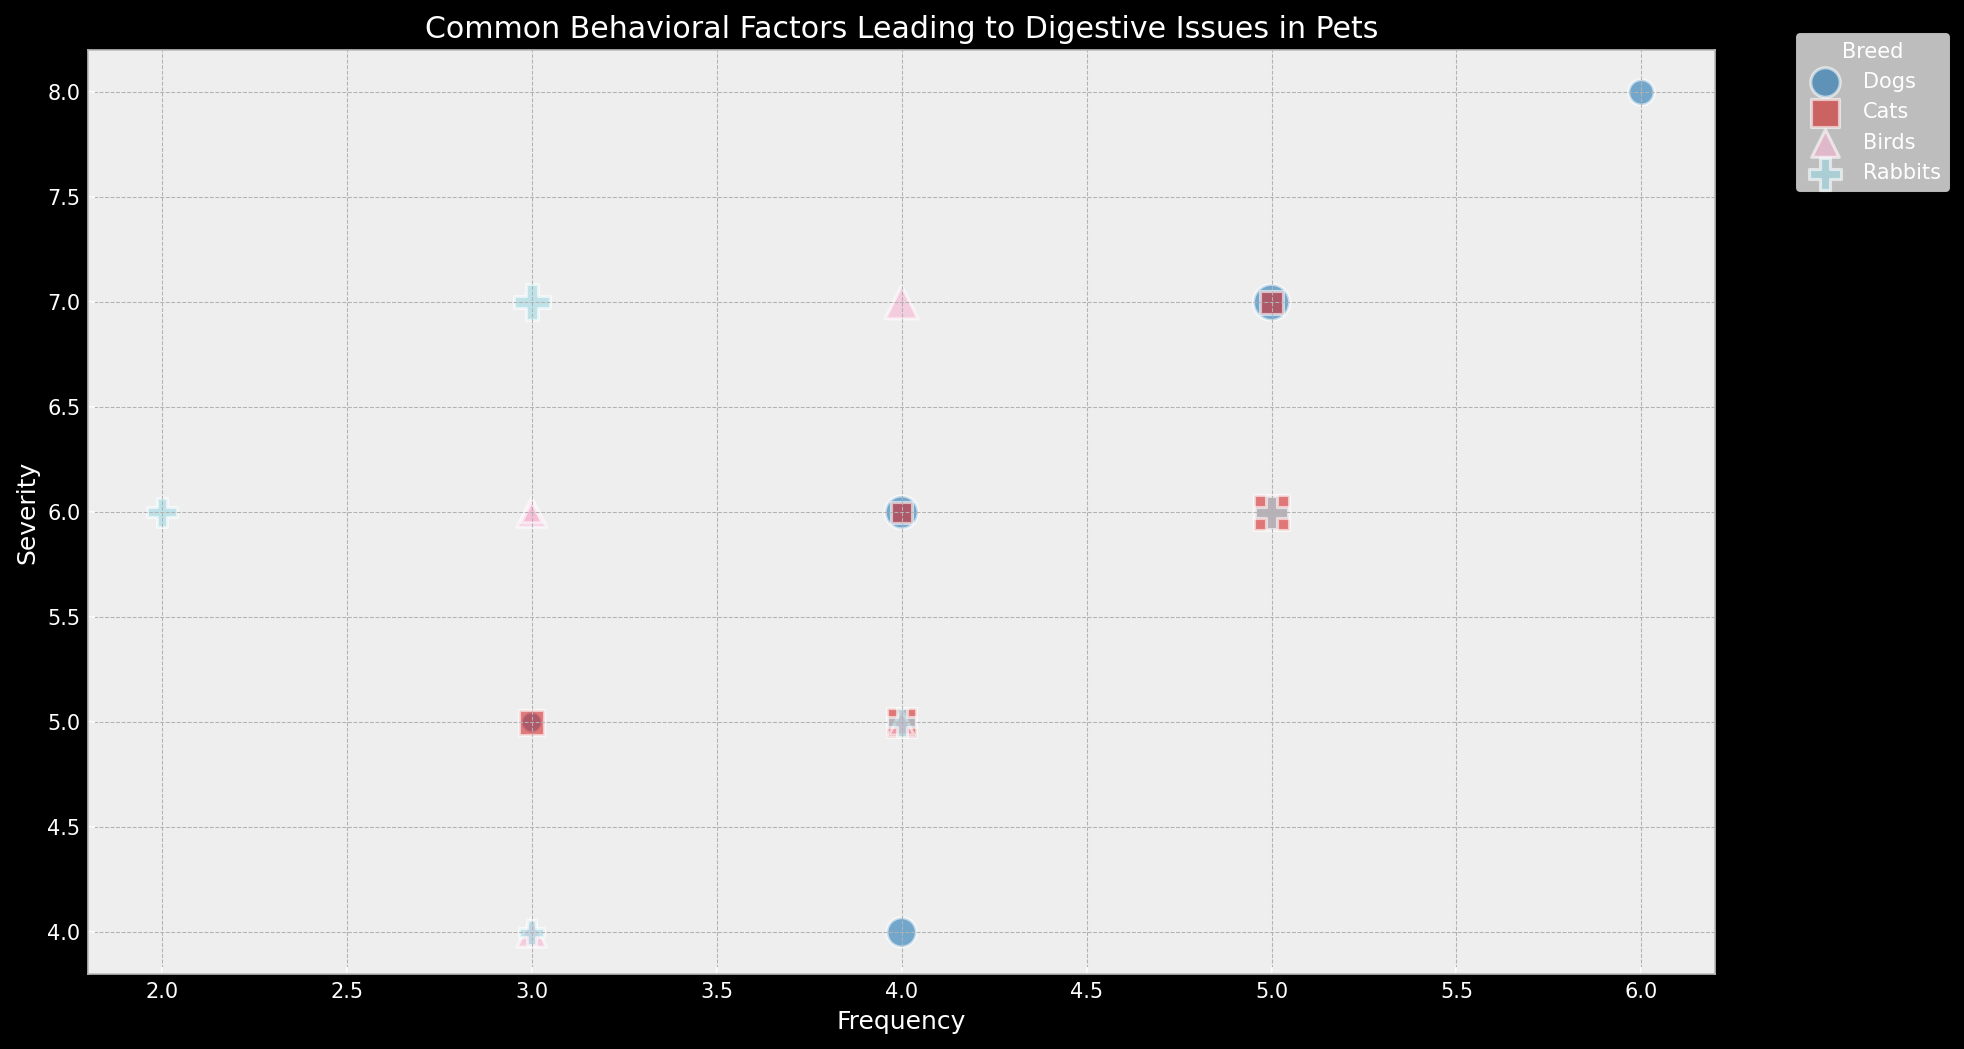What's the most common behavioral factor leading to digestive issues in dogs? By looking for the factor with the largest bubble for Dogs (visual attribute: bubble size), we see Quick_Eating has the largest bubble. This suggests it affects the largest percentage of the dog population, thus making it the most common.
Answer: Quick_Eating Which breed has the least severe common behavioral factor? Comparing the smallest severity values across breeds, the smallest severity score is 4. Both Dogs' Lack_of_Exercise and Birds' Lack_of_Exercise share this severity score. We then check the Population_Percent, and Birds' bubble is smaller within the overlapping bubbles.
Answer: Birds Compare the severity of Anxiety among Dogs, Cats, and Rabbits. Which breed has the highest severity? Looking at the severity axis for Anxiety bubbles for Dogs, Cats, and Rabbits, we see that the severity reaches up to 7 in Dogs and Rabbits, but only 6 for Cats.
Answer: Dogs, Rabbits What is the relationship between the frequency and severity of the behavioral issues for Cats? Observing the bubbles that represent Cats, we correlate the x-axis (Frequency) and y-axis (Severity). The visual pattern shows that as the frequency increases, the severity tends to increase as well, suggesting a positive correlation.
Answer: Positive correlation What behavioral factor in Birds has both a frequency of 4 and a severity of 7? By locating the point where Frequency is 4 and Severity is 7 on the chart, we check for Birds' bubbles. We find Feather_Picking intersects these coordinates.
Answer: Feather_Picking How does the percentage of the population affected by Overeating in Dogs compare to Rabbits? Looking at the size of the bubbles for Overeating in both breeds, Dogs have a slightly smaller bubble compared to Rabbits. Since bubble size correlates with Population_Percent, Rabbits experience Overeating more commonly (25% vs. 20%).
Answer: Rabbits Which behavioral factor shows up with a frequency of 3 but is not common across more than one breed? Points where the frequency is at 3 in the chart and is non-overlapping with other breed colors. Birds' Social_Isolation meets this criterion with single representation on the plot.
Answer: Social_Isolation Among Cats, which behavioral factor has the highest combined score of frequency and severity? To find the highest combined score, add the values of Frequency and Severity for each factor. Eating_Too_Fast has a Frequency of 5 and a Severity of 7. 5 + 7 = 12, which is higher than other factors.
Answer: Eating_Too_Fast What breed is uniquely marked by a big green circle? Observing the colors, considering that green from the tab20 color map is assigned to a specific breed, and matching it with the largest circle (Population_Percent) for that color, we see Dogs have the broadest green circle (30% for Quick_Eating).
Answer: Dogs 